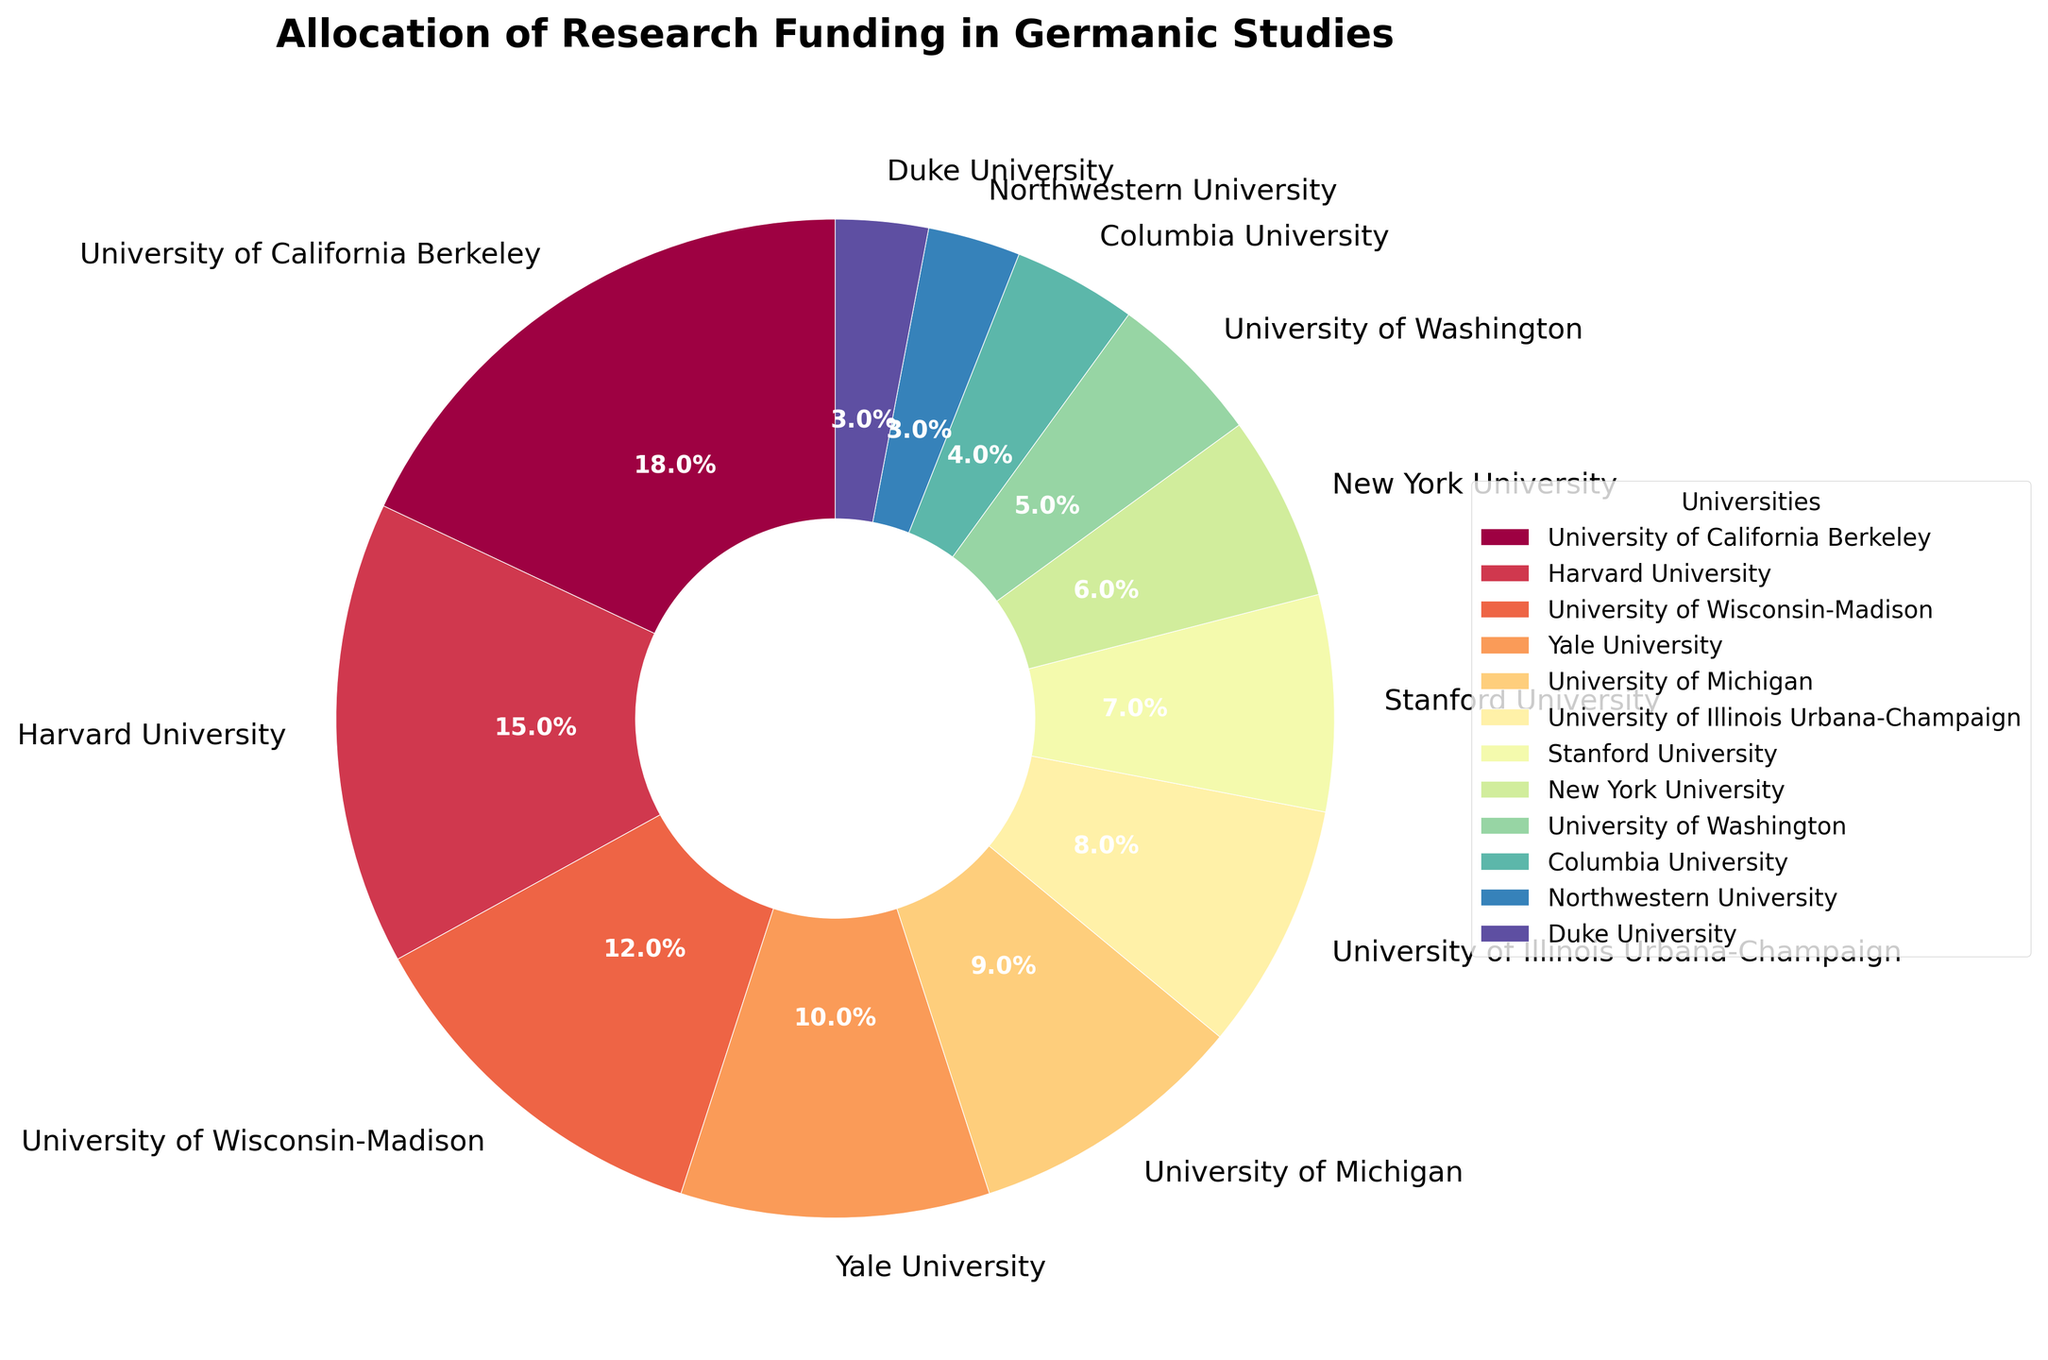Which university has the highest allocation of research funding in Germanic Studies? From the pie chart, the largest wedge is labeled "University of California Berkeley" with 18% allocation, which is the highest among all listed universities.
Answer: University of California Berkeley Which universities have equal research funding allocation in Germanic Studies? Two wedges in the pie chart have identical sizes labeled "Northwestern University" and "Duke University" at 3% allocation each.
Answer: Northwestern University and Duke University How much more funding does Harvard University receive compared to Columbia University? Harvard University has a 15% allocation, while Columbia University has a 4% allocation. The difference is 15 - 4 = 11%.
Answer: 11% What is the total research funding allocation percentage for the universities with less than 10% funding? The universities with less than 10% funding are University of Michigan (9%), University of Illinois Urbana-Champaign (8%), Stanford University (7%), New York University (6%), University of Washington (5%), Columbia University (4%), Northwestern University (3%), and Duke University (3%). Adding these percentages: 9 + 8 + 7 + 6 + 5 + 4 + 3 + 3 = 45%.
Answer: 45% What is the average research funding allocation for Harvard University, University of Wisconsin-Madison, and Yale University? The allocations for Harvard University, University of Wisconsin-Madison, and Yale University are 15%, 12%, and 10%, respectively. The average is (15 + 12 + 10) / 3 = 37 / 3 = 12.33%.
Answer: 12.33% Which university has a funding allocation closest to 10%? Yale University has an allocation of exactly 10%, which is closest to the specified value.
Answer: Yale University Do University of California Berkeley and Harvard University together receive more or less than 30% of the total funding? University of California Berkeley has 18% and Harvard University has 15%. Combined, this is 18 + 15 = 33%, which is more than 30%.
Answer: More How does the funding allocation at Stanford University compare with that at New York University? Stanford University has a 7% allocation, while New York University has a 6% allocation. Thus, Stanford University receives 1% more funding than New York University.
Answer: 1% more Which universities have funding allocations between 5% and 10%? The universities with funding allocations between 5% and 10% are Yale University (10%), University of Michigan (9%), University of Illinois Urbana-Champaign (8%), Stanford University (7%), and New York University (6%).
Answer: Yale University, University of Michigan, University of Illinois Urbana-Champaign, Stanford University, and New York University 